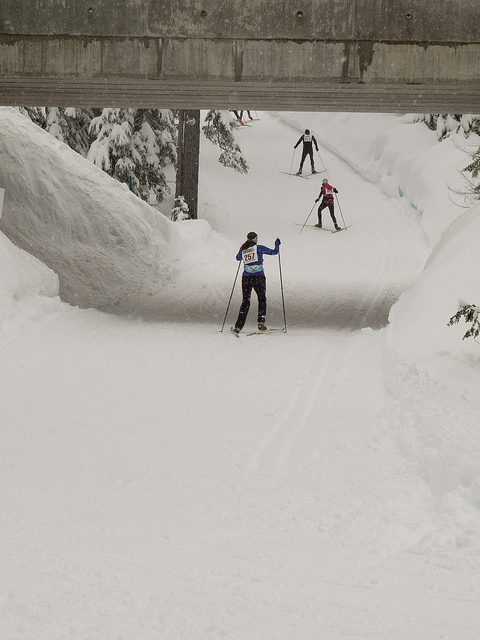<image>How deep is the snow? It's uncertain how deep the snow is. The depth could range from slight to very deep. How deep is the snow? I am not sure how deep the snow is. It can be seen '2 feet', '6 feet', 'slight', '1 foot', '8 inches', 'very deep' or 'very'. 